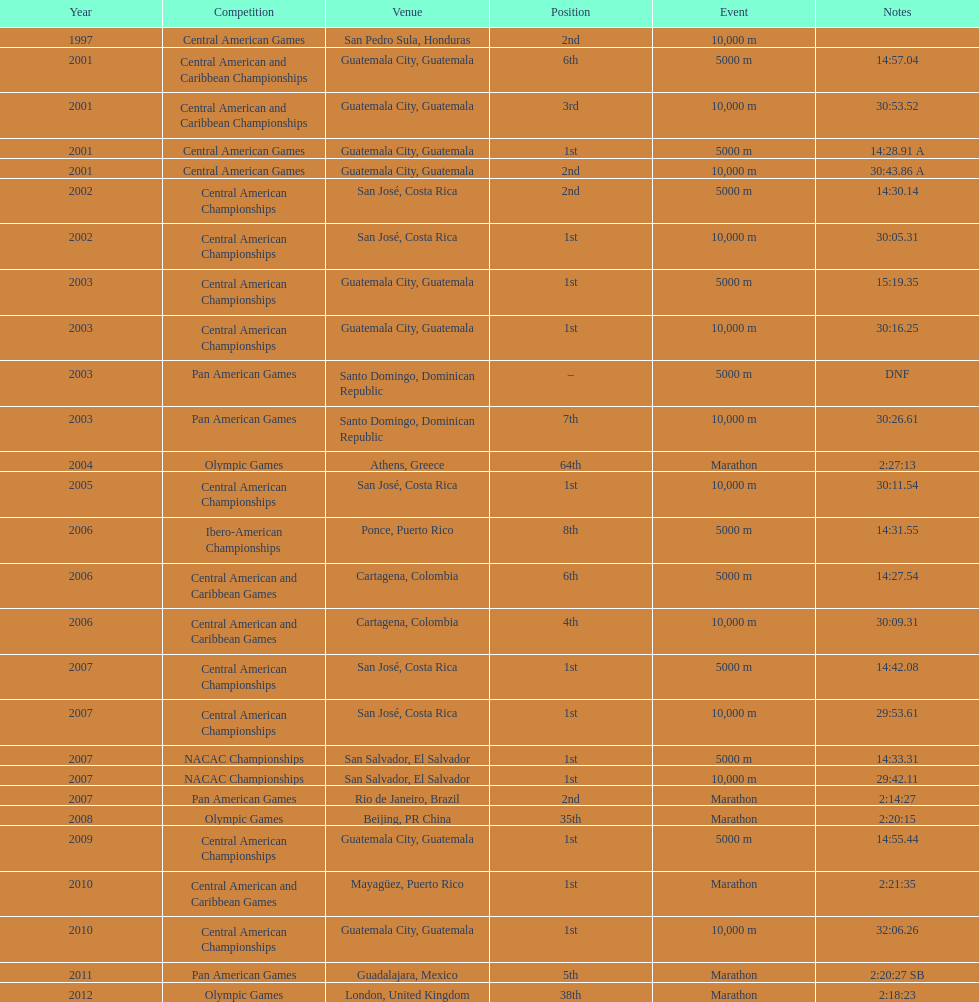At what site was the one and only 64th spot maintained? Athens, Greece. 